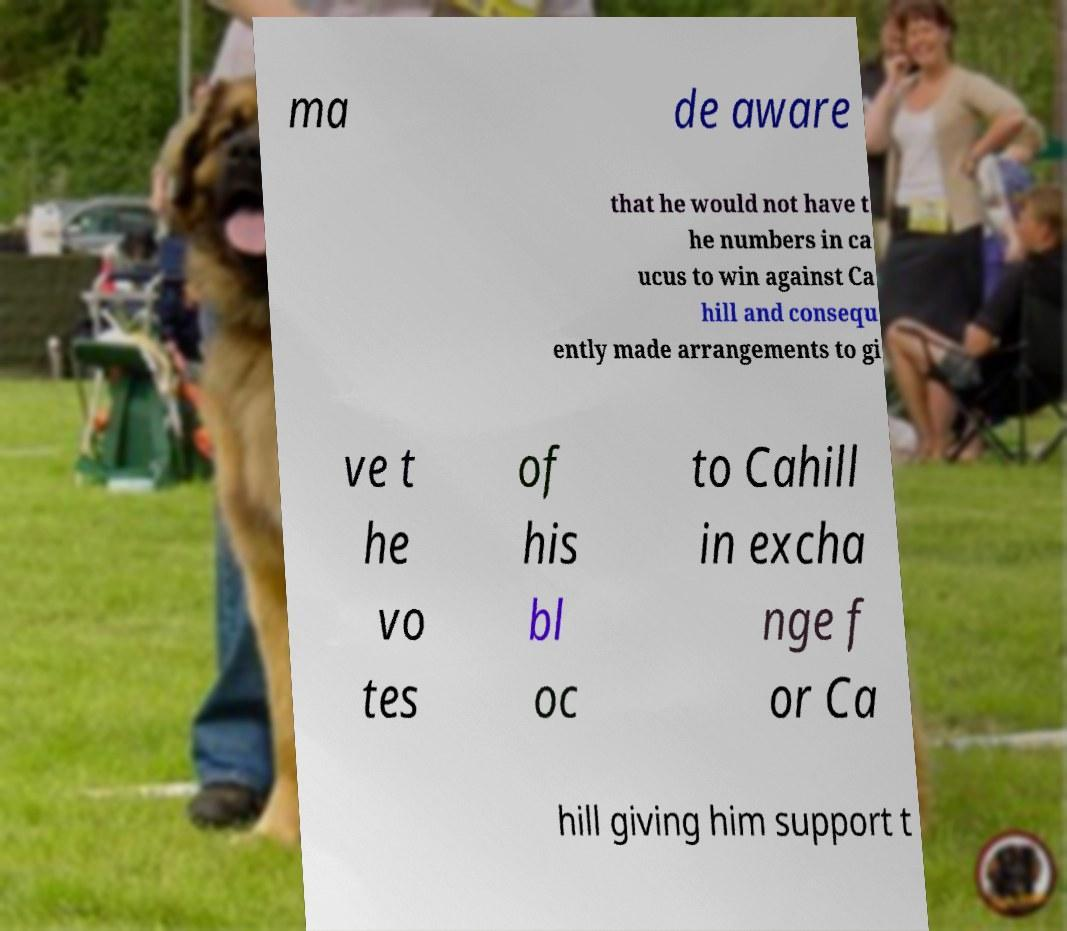Can you accurately transcribe the text from the provided image for me? ma de aware that he would not have t he numbers in ca ucus to win against Ca hill and consequ ently made arrangements to gi ve t he vo tes of his bl oc to Cahill in excha nge f or Ca hill giving him support t 